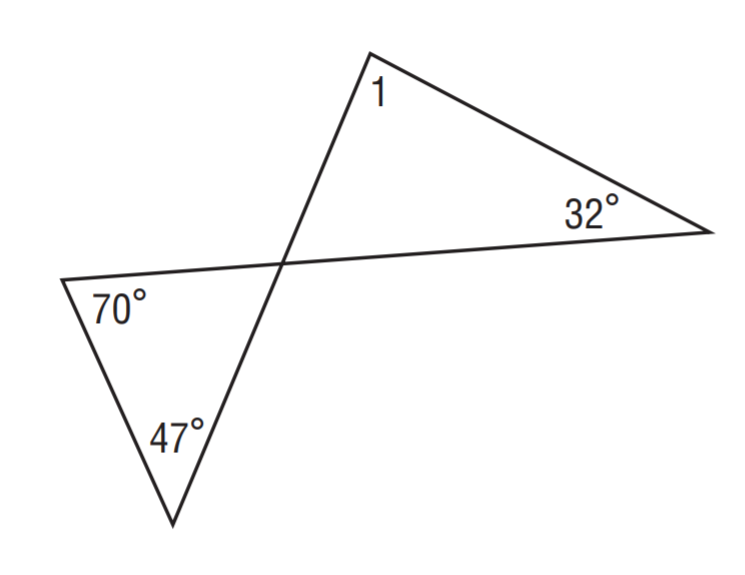Answer the mathemtical geometry problem and directly provide the correct option letter.
Question: Find m \angle 1.
Choices: A: 32 B: 47 C: 70 D: 85 D 